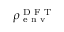Convert formula to latex. <formula><loc_0><loc_0><loc_500><loc_500>\rho _ { e n v } ^ { D F T }</formula> 